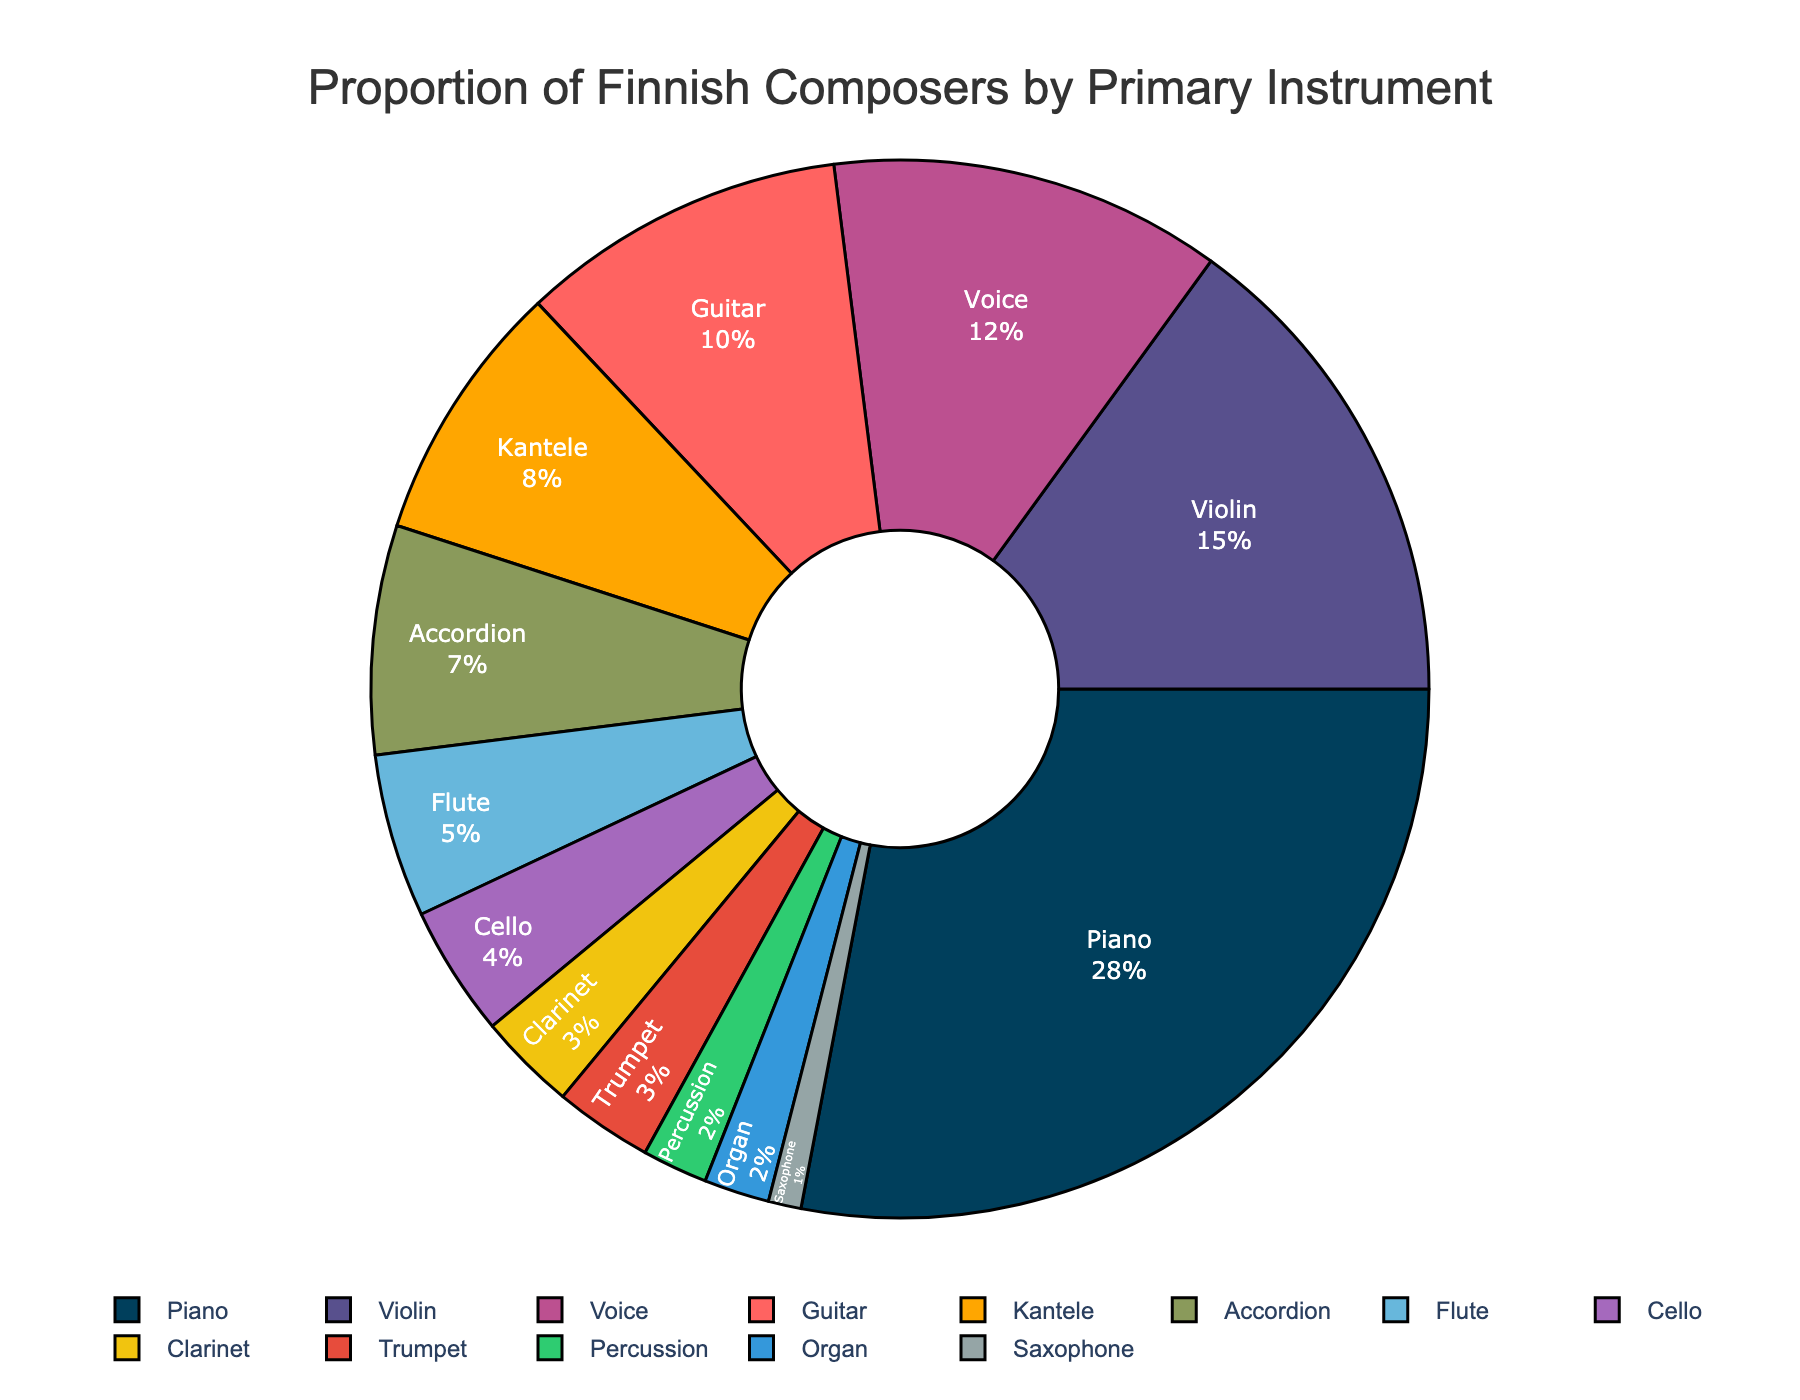What is the most common primary instrument among Finnish composers? The largest segment in the pie chart represents the primary instrument with the highest percentage. The Piano segment at 28% is the largest, making it the most common primary instrument.
Answer: Piano Which instrument category comes next after Piano in terms of the proportion of composers? After identifying Piano at 28%, the next largest segment can be found, which is Violin at 15%.
Answer: Violin What is the combined percentage of composers whose primary instruments are Violin and Guitar? Sum the percentages of the Violin and Guitar segments: 15% + 10%.
Answer: 25% How does the proportion of composers who play the Kantele compare to those who play the Accordion? Identify the segments for Kantele (8%) and Accordion (7%), and see which is larger.
Answer: Kantele is 1% more than Accordion What is the least common primary instrument among the Finnish composers? The smallest segment represents the least common instrument. The Saxophone segment at 1% is the smallest.
Answer: Saxophone What is the difference in percentage between the most and least common primary instruments? Subtract the percentage of the least common instrument (Saxophone, 1%) from the most common instrument (Piano, 28%): 28% - 1%.
Answer: 27% How many different categories of primary instruments are represented by Finnish composers in the dataset? Count the number of different instrument segments in the pie chart. There are 13 segments in total.
Answer: 13 What is the total combined percentage of composers whose primary instruments are in the woodwind category (Flute, Clarinet, Saxophone)? Combine the percentages of Flute (5%), Clarinet (3%), and Saxophone (1%): 5% + 3% + 1%.
Answer: 9% Which primary instrument has almost the same proportion of composers as the Voice category? Identify the percentage for Voice (12%) and then find the segment closest to this value, which is Guitar at 10%.
Answer: Guitar How do the proportions of composers who play Piano compare to those who play string instruments (Violin, Guitar, Cello)? Sum the percentages for the string instruments: Violin (15%) + Guitar (10%) + Cello (4%) = 29%. Compare this to Piano, which is 28%.
Answer: String instruments are 1% more than Piano 